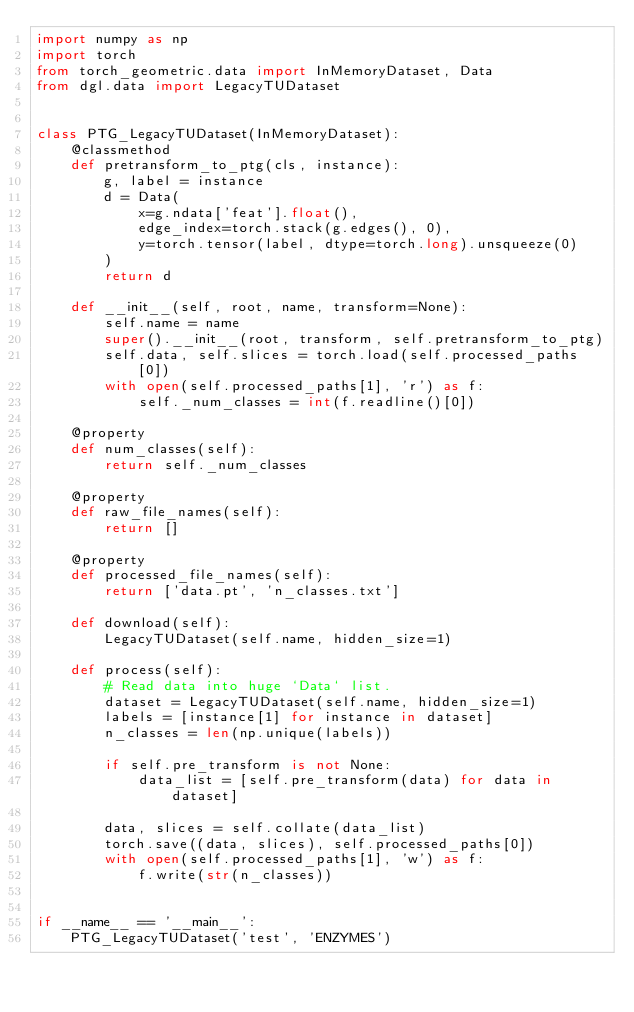<code> <loc_0><loc_0><loc_500><loc_500><_Python_>import numpy as np
import torch
from torch_geometric.data import InMemoryDataset, Data
from dgl.data import LegacyTUDataset


class PTG_LegacyTUDataset(InMemoryDataset):
    @classmethod
    def pretransform_to_ptg(cls, instance):
        g, label = instance
        d = Data(
            x=g.ndata['feat'].float(),
            edge_index=torch.stack(g.edges(), 0),
            y=torch.tensor(label, dtype=torch.long).unsqueeze(0)
        )
        return d

    def __init__(self, root, name, transform=None):
        self.name = name
        super().__init__(root, transform, self.pretransform_to_ptg)
        self.data, self.slices = torch.load(self.processed_paths[0])
        with open(self.processed_paths[1], 'r') as f:
            self._num_classes = int(f.readline()[0])

    @property
    def num_classes(self):
        return self._num_classes

    @property
    def raw_file_names(self):
        return []

    @property
    def processed_file_names(self):
        return ['data.pt', 'n_classes.txt']

    def download(self):
        LegacyTUDataset(self.name, hidden_size=1)

    def process(self):
        # Read data into huge `Data` list.
        dataset = LegacyTUDataset(self.name, hidden_size=1)
        labels = [instance[1] for instance in dataset]
        n_classes = len(np.unique(labels))

        if self.pre_transform is not None:
            data_list = [self.pre_transform(data) for data in dataset]

        data, slices = self.collate(data_list)
        torch.save((data, slices), self.processed_paths[0])
        with open(self.processed_paths[1], 'w') as f:
            f.write(str(n_classes))


if __name__ == '__main__':
    PTG_LegacyTUDataset('test', 'ENZYMES')
</code> 